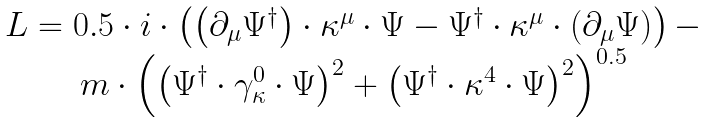Convert formula to latex. <formula><loc_0><loc_0><loc_500><loc_500>\begin{array} { c } L = 0 . 5 \cdot i \cdot \left ( \left ( \partial _ { \mu } \Psi ^ { \dagger } \right ) \cdot \kappa ^ { \mu } \cdot \Psi - \Psi ^ { \dagger } \cdot \kappa ^ { \mu } \cdot \left ( \partial _ { \mu } \Psi \right ) \right ) - \\ m \cdot \left ( \left ( \Psi ^ { \dagger } \cdot \gamma _ { \kappa } ^ { 0 } \cdot \Psi \right ) ^ { 2 } + \left ( \Psi ^ { \dagger } \cdot \kappa ^ { 4 } \cdot \Psi \right ) ^ { 2 } \right ) ^ { 0 . 5 } \end{array}</formula> 